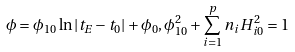<formula> <loc_0><loc_0><loc_500><loc_500>\phi = \phi _ { 1 0 } \ln | t _ { E } - t _ { 0 } | + \phi _ { 0 } , \phi _ { 1 0 } ^ { 2 } + \sum _ { i = 1 } ^ { p } n _ { i } H _ { i 0 } ^ { 2 } = 1</formula> 